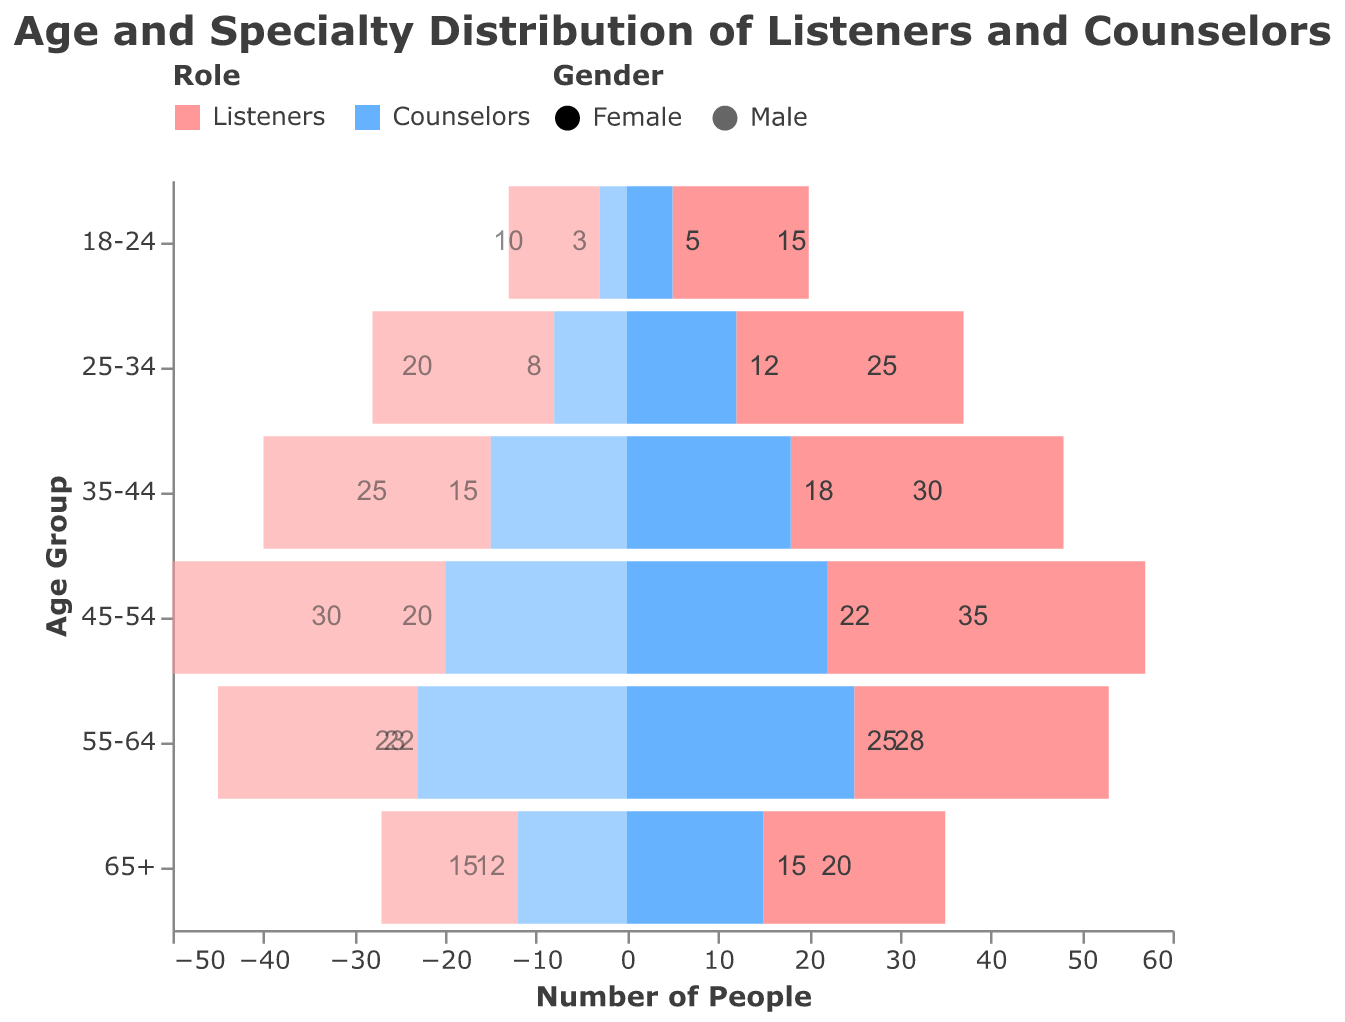What is the title of the figure? The title of the figure is displayed at the top in bold and specifies the topic being visualized. It reads "Age and Specialty Distribution of Listeners and Counselors".
Answer: Age and Specialty Distribution of Listeners and Counselors Which age group has the highest number of female listeners? To determine this, we look at the section of the pyramid representing female listeners and compare the lengths of the bars across different age groups. The 45-54 age group has the highest value for female listeners with 35.
Answer: 45-54 What is the total number of counselors in the 35-44 age group? We add the numbers of female and male counselors in the 35-44 age group. Female Counselors: 18, Male Counselors: 15, Total = 18 + 15.
Answer: 33 How many more female listeners are there compared to male listeners in the 55-64 age group? We subtract the number of male listeners from the number of female listeners in the 55-64 age group. Female Listeners: 28, Male Listeners: 22, Difference = 28 - 22.
Answer: 6 Which gender has more counselors in the 45-54 age group? We compare the number of female counselors to the number of male counselors in the 45-54 age group. Female Counselors: 22, Male Counselors: 20, Female has more.
Answer: Female What is the difference between the youngest and oldest age groups for male counselors? We check the number of male counselors for the 18-24 and 65+ age groups and find the difference. Youngest: 3, Oldest: 12, Difference = 12 - 3.
Answer: 9 Compare the total number of male and female listeners across all age groups. Which gender has more, and by how much? We sum the numbers for male and female listeners across all age groups and compare. Female Listeners: (15 + 25 + 30 + 35 + 28 + 20) = 153, Male Listeners: (10 + 20 + 25 + 30 + 22 + 15) = 122, Difference = 153 - 122.
Answer: Female by 31 Are there more counselors in the 18-24 age group or the 65+ age group? We sum the numbers of female and male counselors for both age groups and compare. 18-24: (5 + 3) = 8, 65+: (15 + 12) = 27, 65+ has more.
Answer: 65+ Which role has a higher number of people in the 45-54 age group, listeners or counselors? We sum the numbers for listeners and counselors in the 45-54 age group and compare. Listeners: (35 + 30) = 65, Counselors: (22 + 20) = 42, Listeners have more.
Answer: Listeners 